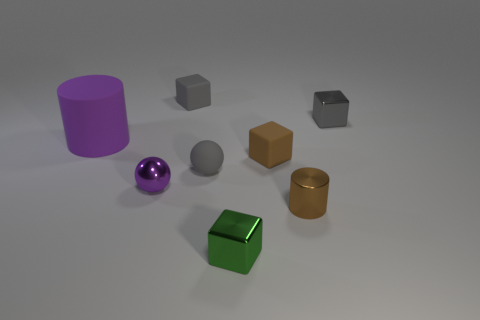Do the small gray thing that is in front of the purple rubber object and the small gray metallic thing have the same shape? No, they do not have the same shape. The small gray object in front of the purple cylinder appears to have a different geometric structure compared to the small gray metallic object. While both items are gray and have a geometric shape, their specific contours and edges differ. 